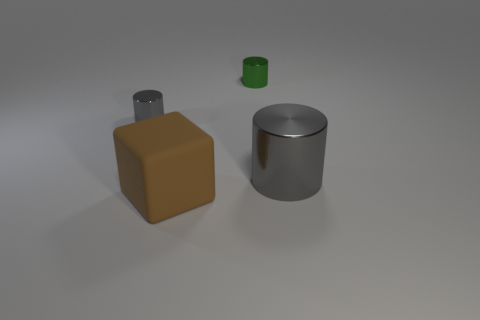What number of other things are the same size as the brown rubber cube?
Your answer should be very brief. 1. There is a gray metal cylinder that is on the left side of the big shiny thing; what is its size?
Give a very brief answer. Small. What number of small green objects have the same material as the tiny gray object?
Your answer should be very brief. 1. Does the metallic object on the left side of the large brown block have the same shape as the green metallic object?
Keep it short and to the point. Yes. There is a gray thing right of the tiny green cylinder; what is its shape?
Provide a succinct answer. Cylinder. What is the material of the large gray object?
Give a very brief answer. Metal. What color is the other shiny thing that is the same size as the green thing?
Your answer should be compact. Gray. The metallic thing that is the same color as the big cylinder is what shape?
Provide a short and direct response. Cylinder. Is the large gray metallic thing the same shape as the small green shiny thing?
Your response must be concise. Yes. What material is the object that is in front of the small gray cylinder and left of the large cylinder?
Give a very brief answer. Rubber. 